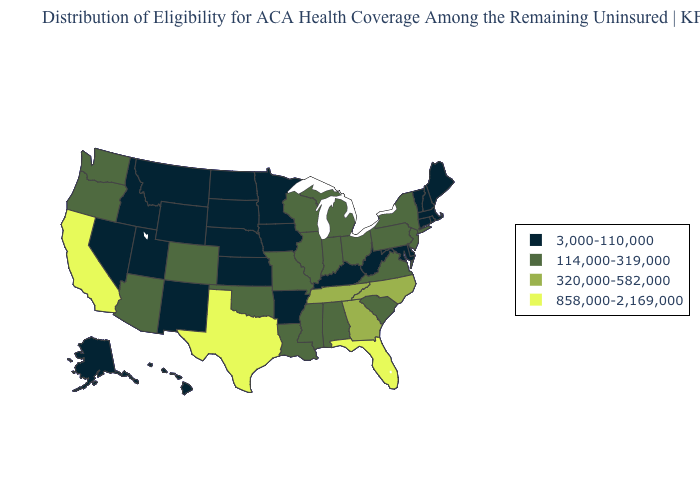Name the states that have a value in the range 858,000-2,169,000?
Concise answer only. California, Florida, Texas. What is the value of New Jersey?
Keep it brief. 114,000-319,000. Which states hav the highest value in the Northeast?
Keep it brief. New Jersey, New York, Pennsylvania. Among the states that border Wisconsin , does Illinois have the lowest value?
Keep it brief. No. Among the states that border New Mexico , does Colorado have the lowest value?
Keep it brief. No. Name the states that have a value in the range 3,000-110,000?
Write a very short answer. Alaska, Arkansas, Connecticut, Delaware, Hawaii, Idaho, Iowa, Kansas, Kentucky, Maine, Maryland, Massachusetts, Minnesota, Montana, Nebraska, Nevada, New Hampshire, New Mexico, North Dakota, Rhode Island, South Dakota, Utah, Vermont, West Virginia, Wyoming. What is the value of New Hampshire?
Keep it brief. 3,000-110,000. Does Oregon have the highest value in the USA?
Be succinct. No. What is the value of Louisiana?
Keep it brief. 114,000-319,000. Name the states that have a value in the range 320,000-582,000?
Be succinct. Georgia, North Carolina, Tennessee. Is the legend a continuous bar?
Keep it brief. No. Does Virginia have the same value as Wyoming?
Concise answer only. No. Which states have the highest value in the USA?
Concise answer only. California, Florida, Texas. Among the states that border New York , does New Jersey have the lowest value?
Answer briefly. No. Among the states that border Minnesota , which have the lowest value?
Short answer required. Iowa, North Dakota, South Dakota. 